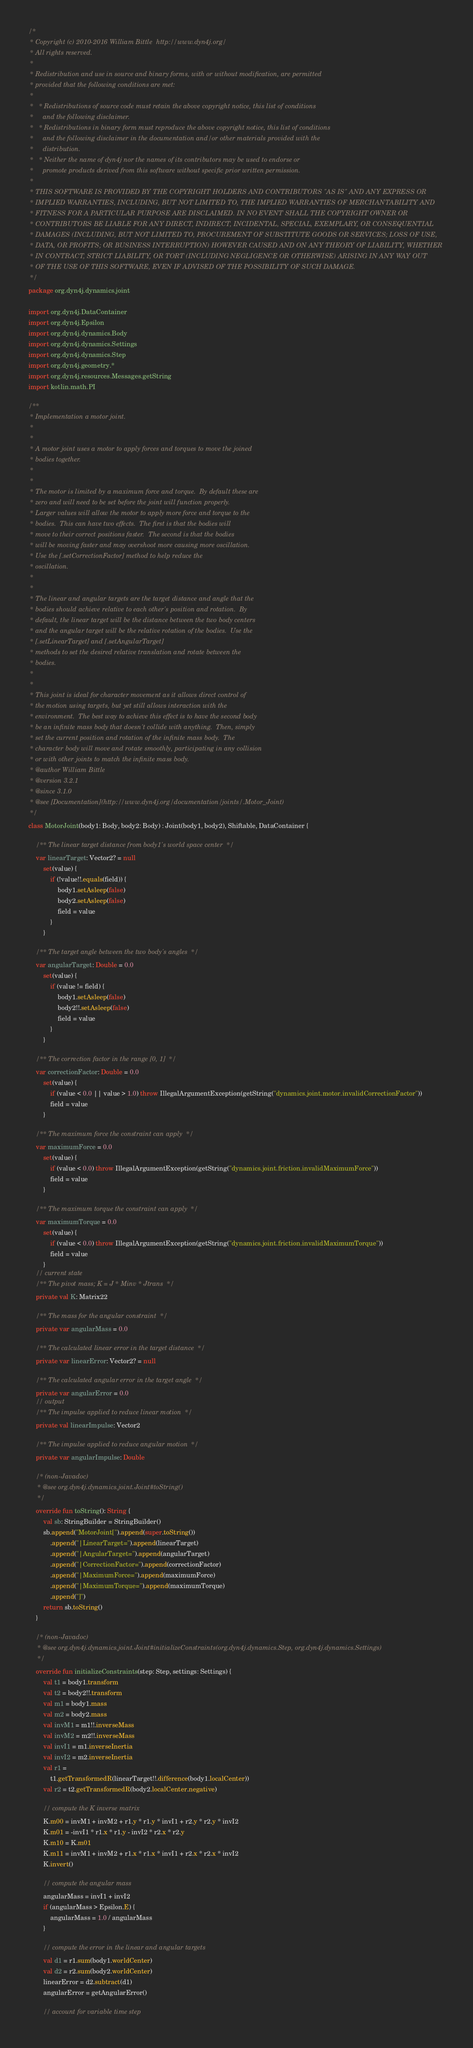<code> <loc_0><loc_0><loc_500><loc_500><_Kotlin_>/*
 * Copyright (c) 2010-2016 William Bittle  http://www.dyn4j.org/
 * All rights reserved.
 * 
 * Redistribution and use in source and binary forms, with or without modification, are permitted 
 * provided that the following conditions are met:
 * 
 *   * Redistributions of source code must retain the above copyright notice, this list of conditions 
 *     and the following disclaimer.
 *   * Redistributions in binary form must reproduce the above copyright notice, this list of conditions 
 *     and the following disclaimer in the documentation and/or other materials provided with the 
 *     distribution.
 *   * Neither the name of dyn4j nor the names of its contributors may be used to endorse or 
 *     promote products derived from this software without specific prior written permission.
 * 
 * THIS SOFTWARE IS PROVIDED BY THE COPYRIGHT HOLDERS AND CONTRIBUTORS "AS IS" AND ANY EXPRESS OR 
 * IMPLIED WARRANTIES, INCLUDING, BUT NOT LIMITED TO, THE IMPLIED WARRANTIES OF MERCHANTABILITY AND 
 * FITNESS FOR A PARTICULAR PURPOSE ARE DISCLAIMED. IN NO EVENT SHALL THE COPYRIGHT OWNER OR 
 * CONTRIBUTORS BE LIABLE FOR ANY DIRECT, INDIRECT, INCIDENTAL, SPECIAL, EXEMPLARY, OR CONSEQUENTIAL 
 * DAMAGES (INCLUDING, BUT NOT LIMITED TO, PROCUREMENT OF SUBSTITUTE GOODS OR SERVICES; LOSS OF USE, 
 * DATA, OR PROFITS; OR BUSINESS INTERRUPTION) HOWEVER CAUSED AND ON ANY THEORY OF LIABILITY, WHETHER 
 * IN CONTRACT, STRICT LIABILITY, OR TORT (INCLUDING NEGLIGENCE OR OTHERWISE) ARISING IN ANY WAY OUT 
 * OF THE USE OF THIS SOFTWARE, EVEN IF ADVISED OF THE POSSIBILITY OF SUCH DAMAGE.
 */
package org.dyn4j.dynamics.joint

import org.dyn4j.DataContainer
import org.dyn4j.Epsilon
import org.dyn4j.dynamics.Body
import org.dyn4j.dynamics.Settings
import org.dyn4j.dynamics.Step
import org.dyn4j.geometry.*
import org.dyn4j.resources.Messages.getString
import kotlin.math.PI

/**
 * Implementation a motor joint.
 *
 *
 * A motor joint uses a motor to apply forces and torques to move the joined
 * bodies together.
 *
 *
 * The motor is limited by a maximum force and torque.  By default these are
 * zero and will need to be set before the joint will function properly.
 * Larger values will allow the motor to apply more force and torque to the
 * bodies.  This can have two effects.  The first is that the bodies will
 * move to their correct positions faster.  The second is that the bodies
 * will be moving faster and may overshoot more causing more oscillation.
 * Use the [.setCorrectionFactor] method to help reduce the
 * oscillation.
 *
 *
 * The linear and angular targets are the target distance and angle that the
 * bodies should achieve relative to each other's position and rotation.  By
 * default, the linear target will be the distance between the two body centers
 * and the angular target will be the relative rotation of the bodies.  Use the
 * [.setLinearTarget] and [.setAngularTarget]
 * methods to set the desired relative translation and rotate between the
 * bodies.
 *
 *
 * This joint is ideal for character movement as it allows direct control of
 * the motion using targets, but yet still allows interaction with the
 * environment.  The best way to achieve this effect is to have the second body
 * be an infinite mass body that doesn't collide with anything.  Then, simply
 * set the current position and rotation of the infinite mass body.  The
 * character body will move and rotate smoothly, participating in any collision
 * or with other joints to match the infinite mass body.
 * @author William Bittle
 * @version 3.2.1
 * @since 3.1.0
 * @see [Documentation](http://www.dyn4j.org/documentation/joints/.Motor_Joint)
 */
class MotorJoint(body1: Body, body2: Body) : Joint(body1, body2), Shiftable, DataContainer {

    /** The linear target distance from body1's world space center  */
    var linearTarget: Vector2? = null
        set(value) {
            if (!value!!.equals(field)) {
                body1.setAsleep(false)
                body2.setAsleep(false)
                field = value
            }
        }

    /** The target angle between the two body's angles  */
    var angularTarget: Double = 0.0
        set(value) {
            if (value != field) {
                body1.setAsleep(false)
                body2!!.setAsleep(false)
                field = value
            }
        }

    /** The correction factor in the range [0, 1]  */
    var correctionFactor: Double = 0.0
        set(value) {
            if (value < 0.0 || value > 1.0) throw IllegalArgumentException(getString("dynamics.joint.motor.invalidCorrectionFactor"))
            field = value
        }

    /** The maximum force the constraint can apply  */
    var maximumForce = 0.0
        set(value) {
            if (value < 0.0) throw IllegalArgumentException(getString("dynamics.joint.friction.invalidMaximumForce"))
            field = value
        }

    /** The maximum torque the constraint can apply  */
    var maximumTorque = 0.0
        set(value) {
            if (value < 0.0) throw IllegalArgumentException(getString("dynamics.joint.friction.invalidMaximumTorque"))
            field = value
        }
    // current state
    /** The pivot mass; K = J * Minv * Jtrans  */
    private val K: Matrix22

    /** The mass for the angular constraint  */
    private var angularMass = 0.0

    /** The calculated linear error in the target distance  */
    private var linearError: Vector2? = null

    /** The calculated angular error in the target angle  */
    private var angularError = 0.0
    // output
    /** The impulse applied to reduce linear motion  */
    private val linearImpulse: Vector2

    /** The impulse applied to reduce angular motion  */
    private var angularImpulse: Double

    /* (non-Javadoc)
	 * @see org.dyn4j.dynamics.joint.Joint#toString()
	 */
    override fun toString(): String {
        val sb: StringBuilder = StringBuilder()
        sb.append("MotorJoint[").append(super.toString())
            .append("|LinearTarget=").append(linearTarget)
            .append("|AngularTarget=").append(angularTarget)
            .append("|CorrectionFactor=").append(correctionFactor)
            .append("|MaximumForce=").append(maximumForce)
            .append("|MaximumTorque=").append(maximumTorque)
            .append("]")
        return sb.toString()
    }

    /* (non-Javadoc)
	 * @see org.dyn4j.dynamics.joint.Joint#initializeConstraints(org.dyn4j.dynamics.Step, org.dyn4j.dynamics.Settings)
	 */
    override fun initializeConstraints(step: Step, settings: Settings) {
        val t1 = body1.transform
        val t2 = body2!!.transform
        val m1 = body1.mass
        val m2 = body2.mass
        val invM1 = m1!!.inverseMass
        val invM2 = m2!!.inverseMass
        val invI1 = m1.inverseInertia
        val invI2 = m2.inverseInertia
        val r1 =
            t1.getTransformedR(linearTarget!!.difference(body1.localCenter))
        val r2 = t2.getTransformedR(body2.localCenter.negative)

        // compute the K inverse matrix
        K.m00 = invM1 + invM2 + r1.y * r1.y * invI1 + r2.y * r2.y * invI2
        K.m01 = -invI1 * r1.x * r1.y - invI2 * r2.x * r2.y
        K.m10 = K.m01
        K.m11 = invM1 + invM2 + r1.x * r1.x * invI1 + r2.x * r2.x * invI2
        K.invert()

        // compute the angular mass
        angularMass = invI1 + invI2
        if (angularMass > Epsilon.E) {
            angularMass = 1.0 / angularMass
        }

        // compute the error in the linear and angular targets
        val d1 = r1.sum(body1.worldCenter)
        val d2 = r2.sum(body2.worldCenter)
        linearError = d2.subtract(d1)
        angularError = getAngularError()

        // account for variable time step</code> 